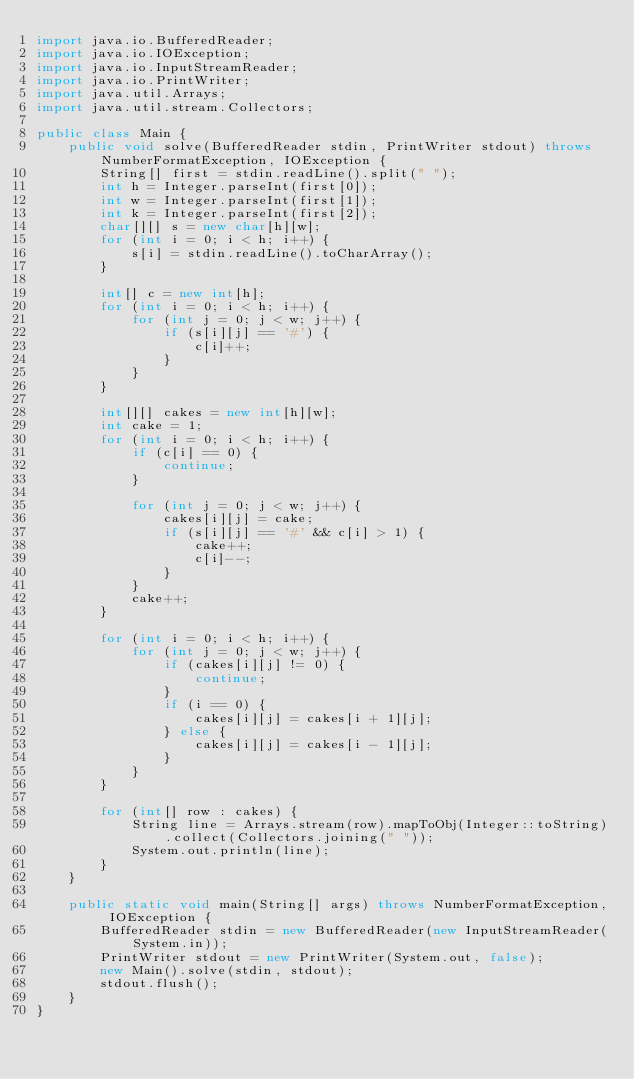<code> <loc_0><loc_0><loc_500><loc_500><_Java_>import java.io.BufferedReader;
import java.io.IOException;
import java.io.InputStreamReader;
import java.io.PrintWriter;
import java.util.Arrays;
import java.util.stream.Collectors;

public class Main {
    public void solve(BufferedReader stdin, PrintWriter stdout) throws NumberFormatException, IOException {
        String[] first = stdin.readLine().split(" ");
        int h = Integer.parseInt(first[0]);
        int w = Integer.parseInt(first[1]);
        int k = Integer.parseInt(first[2]);
        char[][] s = new char[h][w];
        for (int i = 0; i < h; i++) {
            s[i] = stdin.readLine().toCharArray();
        }

        int[] c = new int[h];
        for (int i = 0; i < h; i++) {
            for (int j = 0; j < w; j++) {
                if (s[i][j] == '#') {
                    c[i]++;
                }
            }
        }

        int[][] cakes = new int[h][w];
        int cake = 1;
        for (int i = 0; i < h; i++) {
            if (c[i] == 0) {
                continue;
            }

            for (int j = 0; j < w; j++) {
                cakes[i][j] = cake;
                if (s[i][j] == '#' && c[i] > 1) {
                    cake++;
                    c[i]--;
                }
            }
            cake++;
        }

        for (int i = 0; i < h; i++) {
            for (int j = 0; j < w; j++) {
                if (cakes[i][j] != 0) {
                    continue;
                }
                if (i == 0) {
                    cakes[i][j] = cakes[i + 1][j];
                } else {
                    cakes[i][j] = cakes[i - 1][j];
                }
            }
        }

        for (int[] row : cakes) {
            String line = Arrays.stream(row).mapToObj(Integer::toString).collect(Collectors.joining(" "));
            System.out.println(line);
        }
    }

    public static void main(String[] args) throws NumberFormatException, IOException {
        BufferedReader stdin = new BufferedReader(new InputStreamReader(System.in));
        PrintWriter stdout = new PrintWriter(System.out, false);
        new Main().solve(stdin, stdout);
        stdout.flush();
    }
}
</code> 